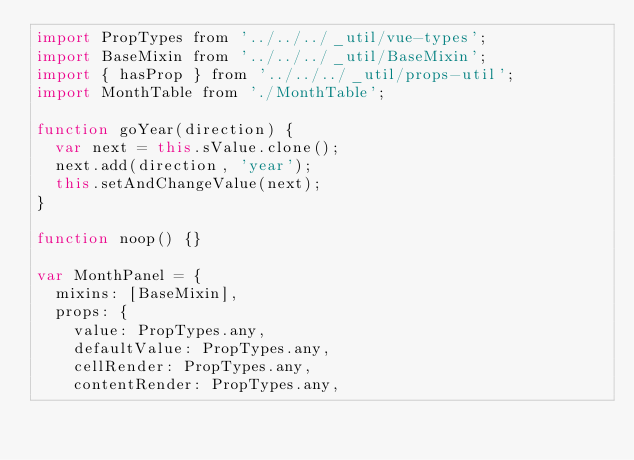Convert code to text. <code><loc_0><loc_0><loc_500><loc_500><_JavaScript_>import PropTypes from '../../../_util/vue-types';
import BaseMixin from '../../../_util/BaseMixin';
import { hasProp } from '../../../_util/props-util';
import MonthTable from './MonthTable';

function goYear(direction) {
  var next = this.sValue.clone();
  next.add(direction, 'year');
  this.setAndChangeValue(next);
}

function noop() {}

var MonthPanel = {
  mixins: [BaseMixin],
  props: {
    value: PropTypes.any,
    defaultValue: PropTypes.any,
    cellRender: PropTypes.any,
    contentRender: PropTypes.any,</code> 